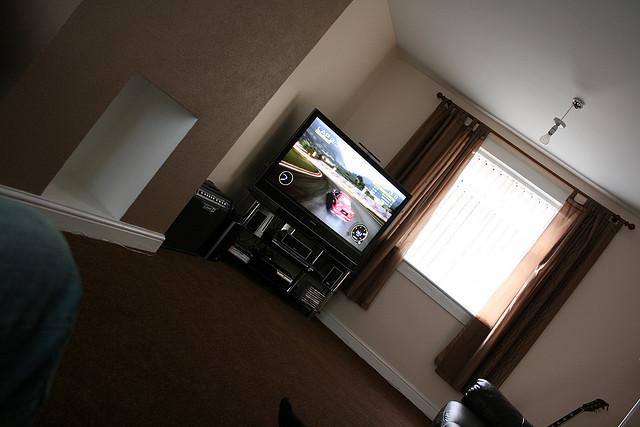Is the light bulb on the ceiling on or off?
Concise answer only. Off. Is it day or night?
Short answer required. Day. How many people are watching the TV?
Be succinct. 1. 